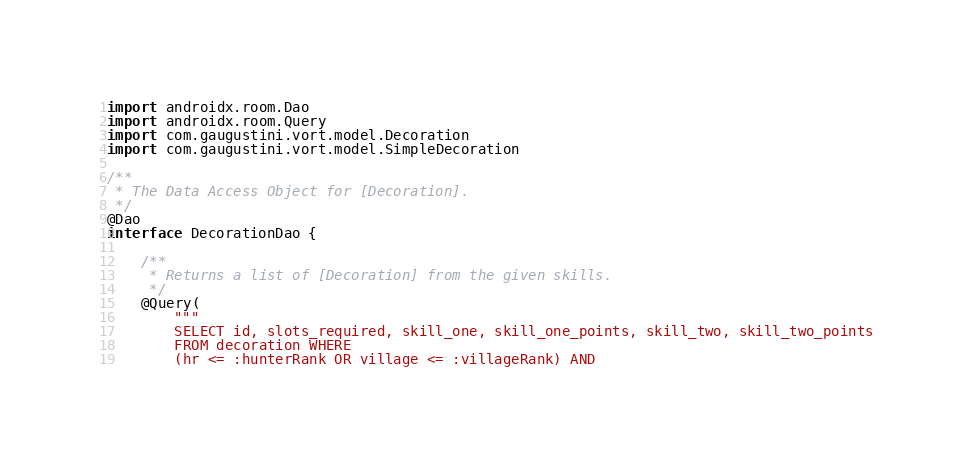<code> <loc_0><loc_0><loc_500><loc_500><_Kotlin_>
import androidx.room.Dao
import androidx.room.Query
import com.gaugustini.vort.model.Decoration
import com.gaugustini.vort.model.SimpleDecoration

/**
 * The Data Access Object for [Decoration].
 */
@Dao
interface DecorationDao {

    /**
     * Returns a list of [Decoration] from the given skills.
     */
    @Query(
        """
        SELECT id, slots_required, skill_one, skill_one_points, skill_two, skill_two_points
        FROM decoration WHERE
        (hr <= :hunterRank OR village <= :villageRank) AND</code> 